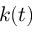<formula> <loc_0><loc_0><loc_500><loc_500>k ( t )</formula> 